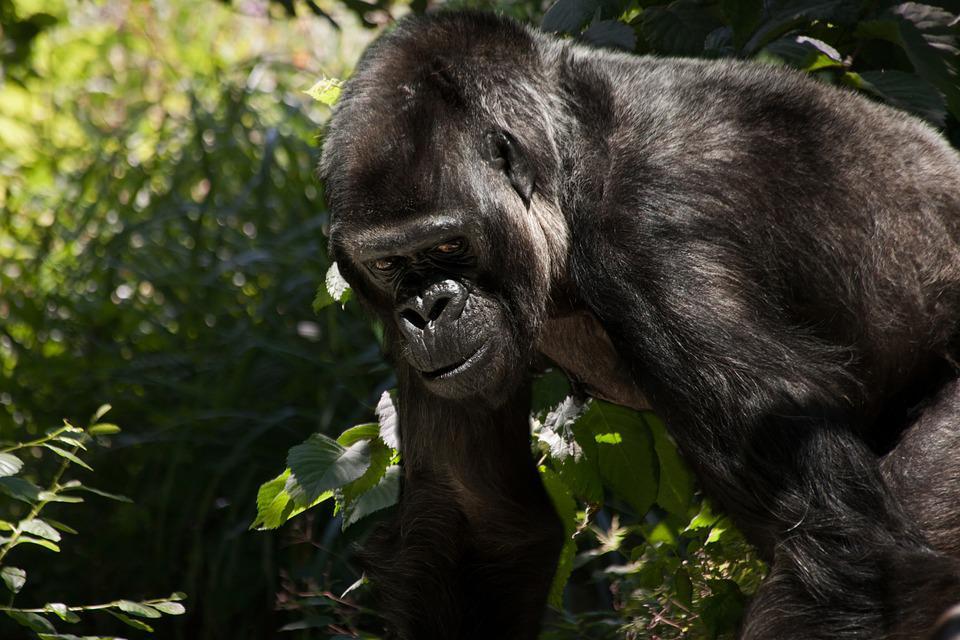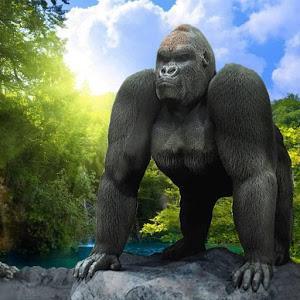The first image is the image on the left, the second image is the image on the right. For the images displayed, is the sentence "There is one sitting gorilla in the image on the right." factually correct? Answer yes or no. No. 